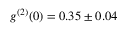Convert formula to latex. <formula><loc_0><loc_0><loc_500><loc_500>g ^ { ( 2 ) } ( 0 ) = 0 . 3 5 \pm 0 . 0 4</formula> 